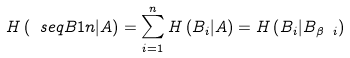Convert formula to latex. <formula><loc_0><loc_0><loc_500><loc_500>H \left ( \ s e q B 1 n | A \right ) = \sum _ { i = 1 } ^ { n } H \left ( B _ { i } | A \right ) = H \left ( B _ { i } | B _ { \beta \ i } \right )</formula> 